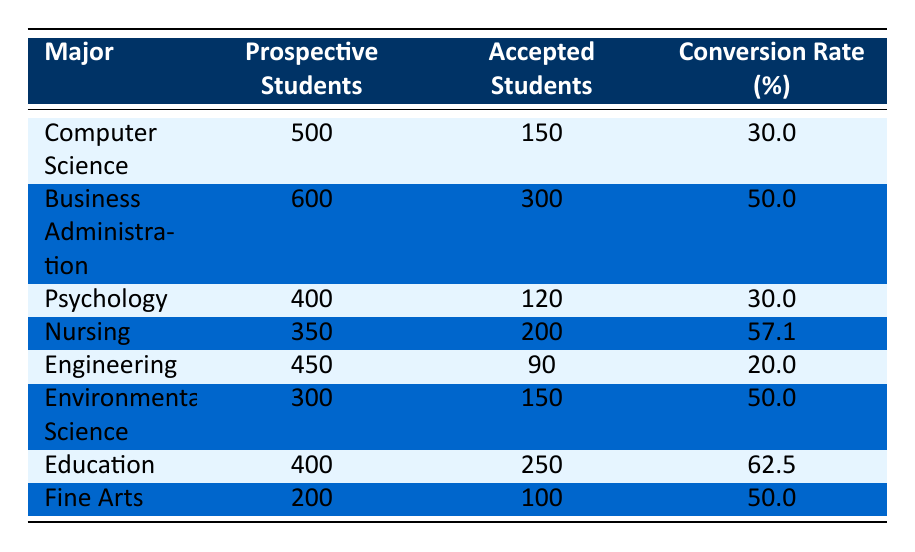What is the conversion rate for Nursing? The conversion rate for Nursing is listed directly in the table under the Nursing row, which states 57.1%.
Answer: 57.1 Which major has the highest conversion rate? By comparing the conversion rates in the table, Education has the highest conversion rate of 62.5%.
Answer: Education How many prospective students are there for Business Administration? The table provides the number of prospective students for Business Administration as 600, found in the corresponding row.
Answer: 600 What is the average conversion rate for all majors listed? To find the average conversion rate, add all conversion rates: (30.0 + 50.0 + 30.0 + 57.1 + 20.0 + 50.0 + 62.5 + 50.0) = 300.6. Then, divide by the number of majors (8): 300.6 / 8 = 37.575.
Answer: 37.575 Is it true that Fine Arts has a higher conversion rate than Engineering? Comparing the conversion rates in the table, Fine Arts has a conversion rate of 50.0%, while Engineering has 20.0%, so the statement is true.
Answer: Yes How many accepted students are there in total across all majors? To find the total accepted students, sum the accepted students column: (150 + 300 + 120 + 200 + 90 + 150 + 250 + 100) = 1,460.
Answer: 1460 Which major has the lowest number of accepted students? Looking at the accepted students column in the table, Engineering has the lowest number of accepted students at 90.
Answer: Engineering Does Psychology have a higher number of accepted students than Computer Science? In the table, Psychology has 120 accepted students and Computer Science has 150. Since 120 is less than 150, the statement is false.
Answer: No 